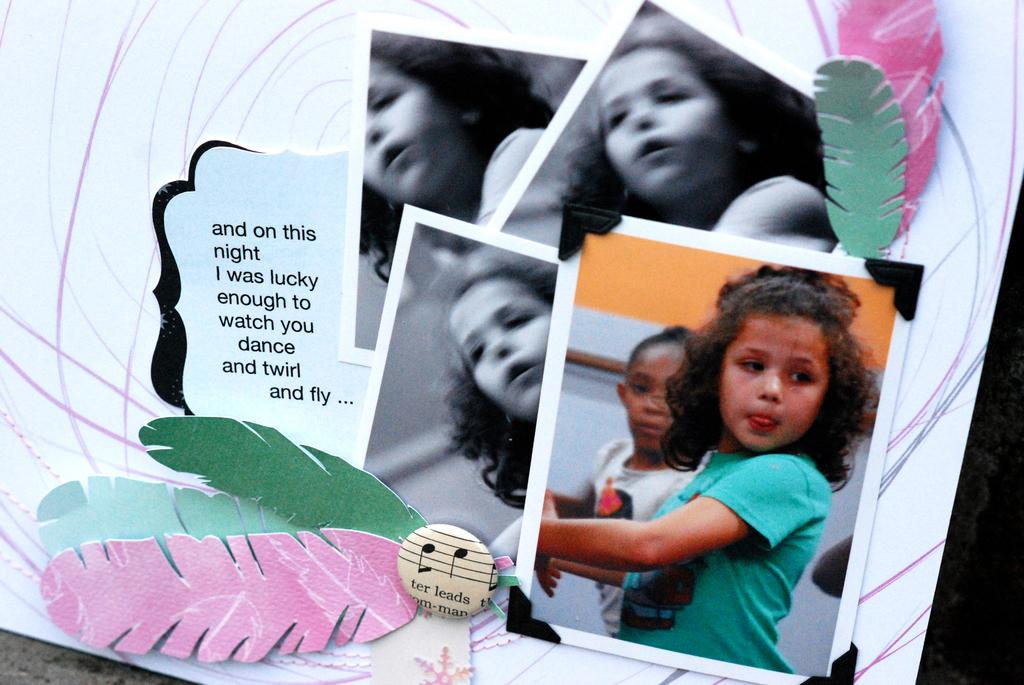What is the main object in the image? There is a board in the image. What can be seen on the board? The board has photos of a girl on it, feathers, and text. What is the color of the background in the image? The background of the image is dark. How many eggs are visible on the board in the image? There are no eggs present on the board in the image. What type of badge is the girl wearing in the image? There is no girl wearing a badge in the image; the board has photos of a girl, but no indication of a badge. 